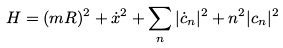Convert formula to latex. <formula><loc_0><loc_0><loc_500><loc_500>H = ( m R ) ^ { 2 } + { \dot { x } } ^ { 2 } + \sum _ { n } | { \dot { c } } _ { n } | ^ { 2 } + n ^ { 2 } | c _ { n } | ^ { 2 }</formula> 